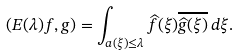<formula> <loc_0><loc_0><loc_500><loc_500>( E ( \lambda ) f , g ) = \int _ { a ( \xi ) \leq \lambda } \widehat { f } ( \xi ) \overline { \widehat { g } ( \xi ) } \, d \xi .</formula> 